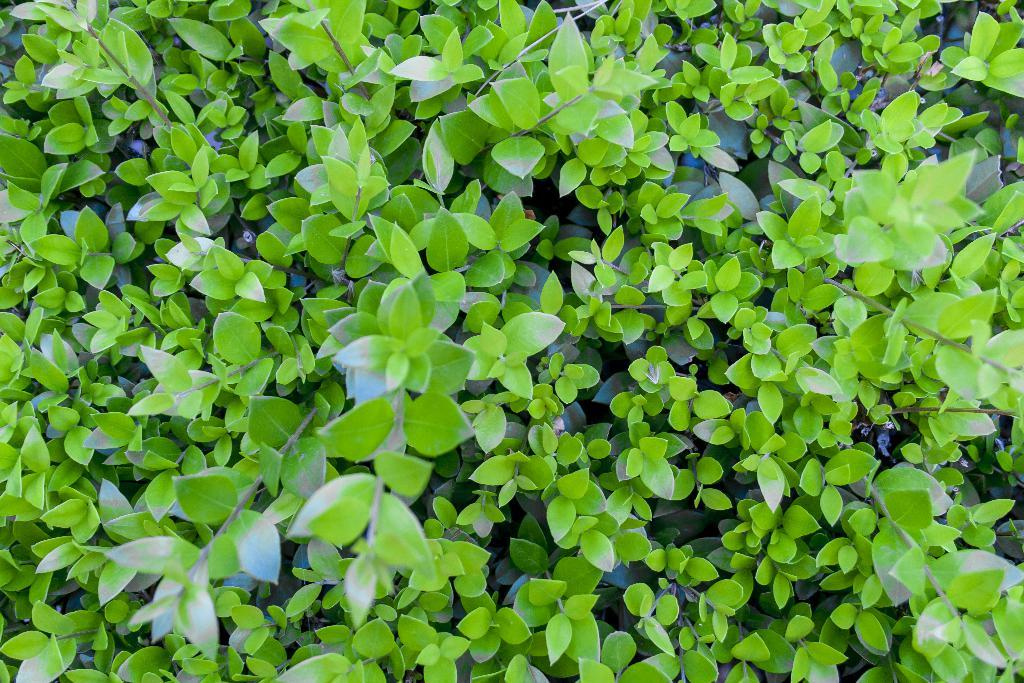What type of living organisms are in the image? The image contains plants. What specific parts of the plants can be seen in the image? The plants have leaves and stems. What time of day is it in the image? The time of day is not visible or mentioned in the image, so it cannot be determined. Is there any quicksand present in the image? There is no quicksand present in the image. Can you see the toes of any person in the image? There are no people or body parts visible in the image. 